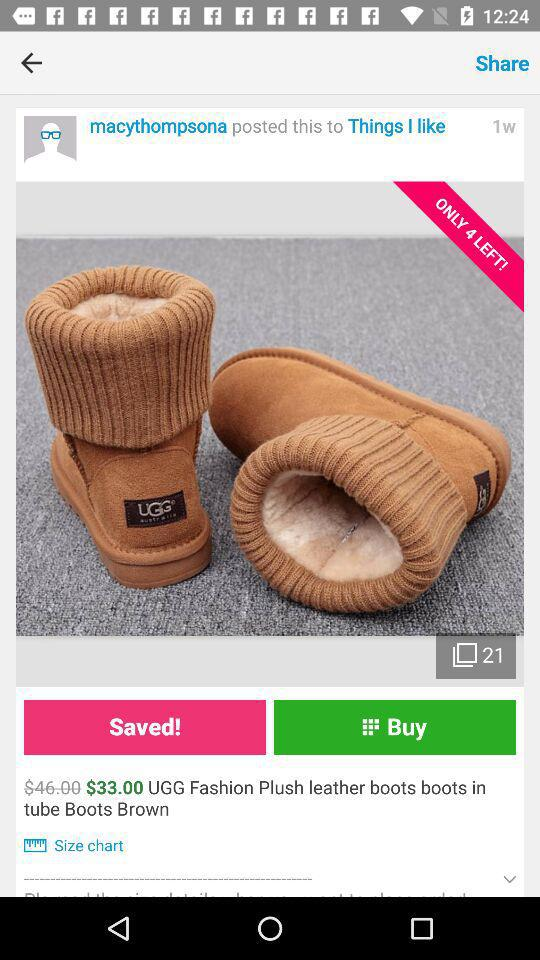What is the price of leather boots after a discount? The price after the discount is $33. 